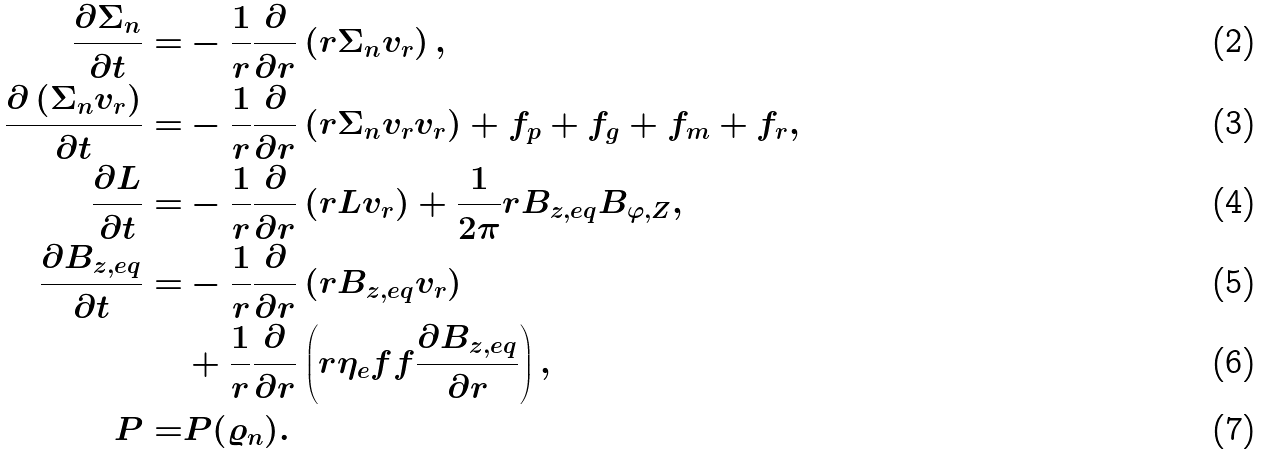Convert formula to latex. <formula><loc_0><loc_0><loc_500><loc_500>\frac { \partial \Sigma _ { n } } { \partial t } = & - \frac { 1 } { r } \frac { \partial } { \partial r } \left ( r \Sigma _ { n } v _ { r } \right ) , \\ \frac { \partial \left ( \Sigma _ { n } v _ { r } \right ) } { \partial t } = & - \frac { 1 } { r } \frac { \partial } { \partial r } \left ( r \Sigma _ { n } v _ { r } v _ { r } \right ) + f _ { p } + f _ { g } + f _ { m } + f _ { r } , \\ \frac { \partial L } { \partial t } = & - \frac { 1 } { r } \frac { \partial } { \partial r } \left ( r L v _ { r } \right ) + \frac { 1 } { 2 \pi } r B _ { z , e q } B _ { \varphi , Z } , \\ \frac { \partial B _ { z , e q } } { \partial t } = & - \frac { 1 } { r } \frac { \partial } { \partial r } \left ( r B _ { z , e q } v _ { r } \right ) \\ & + \frac { 1 } { r } \frac { \partial } { \partial r } \left ( r \eta _ { e } f f \frac { \partial B _ { z , e q } } { \partial r } \right ) , \\ P = & P ( \varrho _ { n } ) .</formula> 